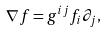<formula> <loc_0><loc_0><loc_500><loc_500>\nabla f = g ^ { i j } f _ { i } \partial _ { j } ,</formula> 